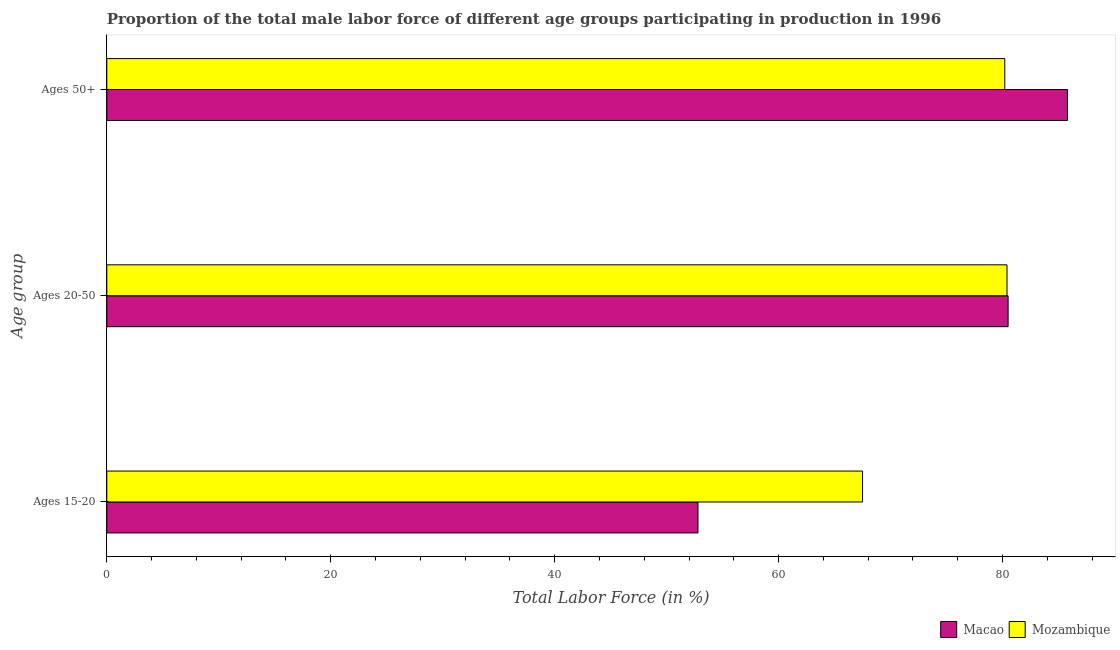How many different coloured bars are there?
Ensure brevity in your answer.  2. Are the number of bars on each tick of the Y-axis equal?
Your answer should be very brief. Yes. How many bars are there on the 1st tick from the bottom?
Give a very brief answer. 2. What is the label of the 3rd group of bars from the top?
Provide a succinct answer. Ages 15-20. What is the percentage of male labor force within the age group 15-20 in Macao?
Offer a terse response. 52.8. Across all countries, what is the maximum percentage of male labor force within the age group 15-20?
Offer a very short reply. 67.5. Across all countries, what is the minimum percentage of male labor force within the age group 20-50?
Offer a very short reply. 80.4. In which country was the percentage of male labor force above age 50 maximum?
Provide a succinct answer. Macao. In which country was the percentage of male labor force within the age group 15-20 minimum?
Your answer should be very brief. Macao. What is the total percentage of male labor force within the age group 15-20 in the graph?
Provide a short and direct response. 120.3. What is the difference between the percentage of male labor force above age 50 in Macao and that in Mozambique?
Offer a terse response. 5.6. What is the difference between the percentage of male labor force above age 50 in Macao and the percentage of male labor force within the age group 20-50 in Mozambique?
Provide a succinct answer. 5.4. What is the average percentage of male labor force within the age group 20-50 per country?
Your answer should be very brief. 80.45. What is the difference between the percentage of male labor force within the age group 20-50 and percentage of male labor force above age 50 in Macao?
Make the answer very short. -5.3. In how many countries, is the percentage of male labor force within the age group 15-20 greater than 8 %?
Give a very brief answer. 2. What is the ratio of the percentage of male labor force within the age group 20-50 in Mozambique to that in Macao?
Your response must be concise. 1. Is the difference between the percentage of male labor force within the age group 15-20 in Macao and Mozambique greater than the difference between the percentage of male labor force within the age group 20-50 in Macao and Mozambique?
Give a very brief answer. No. What is the difference between the highest and the second highest percentage of male labor force above age 50?
Make the answer very short. 5.6. What is the difference between the highest and the lowest percentage of male labor force within the age group 20-50?
Keep it short and to the point. 0.1. What does the 2nd bar from the top in Ages 15-20 represents?
Provide a succinct answer. Macao. What does the 1st bar from the bottom in Ages 50+ represents?
Your answer should be very brief. Macao. How many bars are there?
Keep it short and to the point. 6. What is the difference between two consecutive major ticks on the X-axis?
Your answer should be very brief. 20. Does the graph contain any zero values?
Offer a terse response. No. Does the graph contain grids?
Your answer should be compact. No. Where does the legend appear in the graph?
Keep it short and to the point. Bottom right. How many legend labels are there?
Provide a succinct answer. 2. How are the legend labels stacked?
Your answer should be very brief. Horizontal. What is the title of the graph?
Your answer should be very brief. Proportion of the total male labor force of different age groups participating in production in 1996. Does "Estonia" appear as one of the legend labels in the graph?
Offer a very short reply. No. What is the label or title of the X-axis?
Provide a succinct answer. Total Labor Force (in %). What is the label or title of the Y-axis?
Keep it short and to the point. Age group. What is the Total Labor Force (in %) in Macao in Ages 15-20?
Offer a very short reply. 52.8. What is the Total Labor Force (in %) of Mozambique in Ages 15-20?
Ensure brevity in your answer.  67.5. What is the Total Labor Force (in %) of Macao in Ages 20-50?
Your response must be concise. 80.5. What is the Total Labor Force (in %) in Mozambique in Ages 20-50?
Offer a terse response. 80.4. What is the Total Labor Force (in %) in Macao in Ages 50+?
Offer a terse response. 85.8. What is the Total Labor Force (in %) in Mozambique in Ages 50+?
Your response must be concise. 80.2. Across all Age group, what is the maximum Total Labor Force (in %) in Macao?
Give a very brief answer. 85.8. Across all Age group, what is the maximum Total Labor Force (in %) in Mozambique?
Make the answer very short. 80.4. Across all Age group, what is the minimum Total Labor Force (in %) in Macao?
Provide a succinct answer. 52.8. Across all Age group, what is the minimum Total Labor Force (in %) in Mozambique?
Keep it short and to the point. 67.5. What is the total Total Labor Force (in %) of Macao in the graph?
Your response must be concise. 219.1. What is the total Total Labor Force (in %) of Mozambique in the graph?
Your response must be concise. 228.1. What is the difference between the Total Labor Force (in %) of Macao in Ages 15-20 and that in Ages 20-50?
Provide a succinct answer. -27.7. What is the difference between the Total Labor Force (in %) in Macao in Ages 15-20 and that in Ages 50+?
Your answer should be very brief. -33. What is the difference between the Total Labor Force (in %) in Mozambique in Ages 20-50 and that in Ages 50+?
Ensure brevity in your answer.  0.2. What is the difference between the Total Labor Force (in %) of Macao in Ages 15-20 and the Total Labor Force (in %) of Mozambique in Ages 20-50?
Keep it short and to the point. -27.6. What is the difference between the Total Labor Force (in %) in Macao in Ages 15-20 and the Total Labor Force (in %) in Mozambique in Ages 50+?
Your response must be concise. -27.4. What is the difference between the Total Labor Force (in %) of Macao in Ages 20-50 and the Total Labor Force (in %) of Mozambique in Ages 50+?
Provide a succinct answer. 0.3. What is the average Total Labor Force (in %) in Macao per Age group?
Your answer should be compact. 73.03. What is the average Total Labor Force (in %) of Mozambique per Age group?
Keep it short and to the point. 76.03. What is the difference between the Total Labor Force (in %) in Macao and Total Labor Force (in %) in Mozambique in Ages 15-20?
Offer a very short reply. -14.7. What is the ratio of the Total Labor Force (in %) of Macao in Ages 15-20 to that in Ages 20-50?
Provide a short and direct response. 0.66. What is the ratio of the Total Labor Force (in %) of Mozambique in Ages 15-20 to that in Ages 20-50?
Offer a very short reply. 0.84. What is the ratio of the Total Labor Force (in %) of Macao in Ages 15-20 to that in Ages 50+?
Your answer should be compact. 0.62. What is the ratio of the Total Labor Force (in %) of Mozambique in Ages 15-20 to that in Ages 50+?
Ensure brevity in your answer.  0.84. What is the ratio of the Total Labor Force (in %) of Macao in Ages 20-50 to that in Ages 50+?
Provide a short and direct response. 0.94. What is the ratio of the Total Labor Force (in %) in Mozambique in Ages 20-50 to that in Ages 50+?
Your answer should be very brief. 1. What is the difference between the highest and the second highest Total Labor Force (in %) of Macao?
Provide a short and direct response. 5.3. What is the difference between the highest and the second highest Total Labor Force (in %) in Mozambique?
Keep it short and to the point. 0.2. What is the difference between the highest and the lowest Total Labor Force (in %) in Macao?
Keep it short and to the point. 33. What is the difference between the highest and the lowest Total Labor Force (in %) in Mozambique?
Make the answer very short. 12.9. 